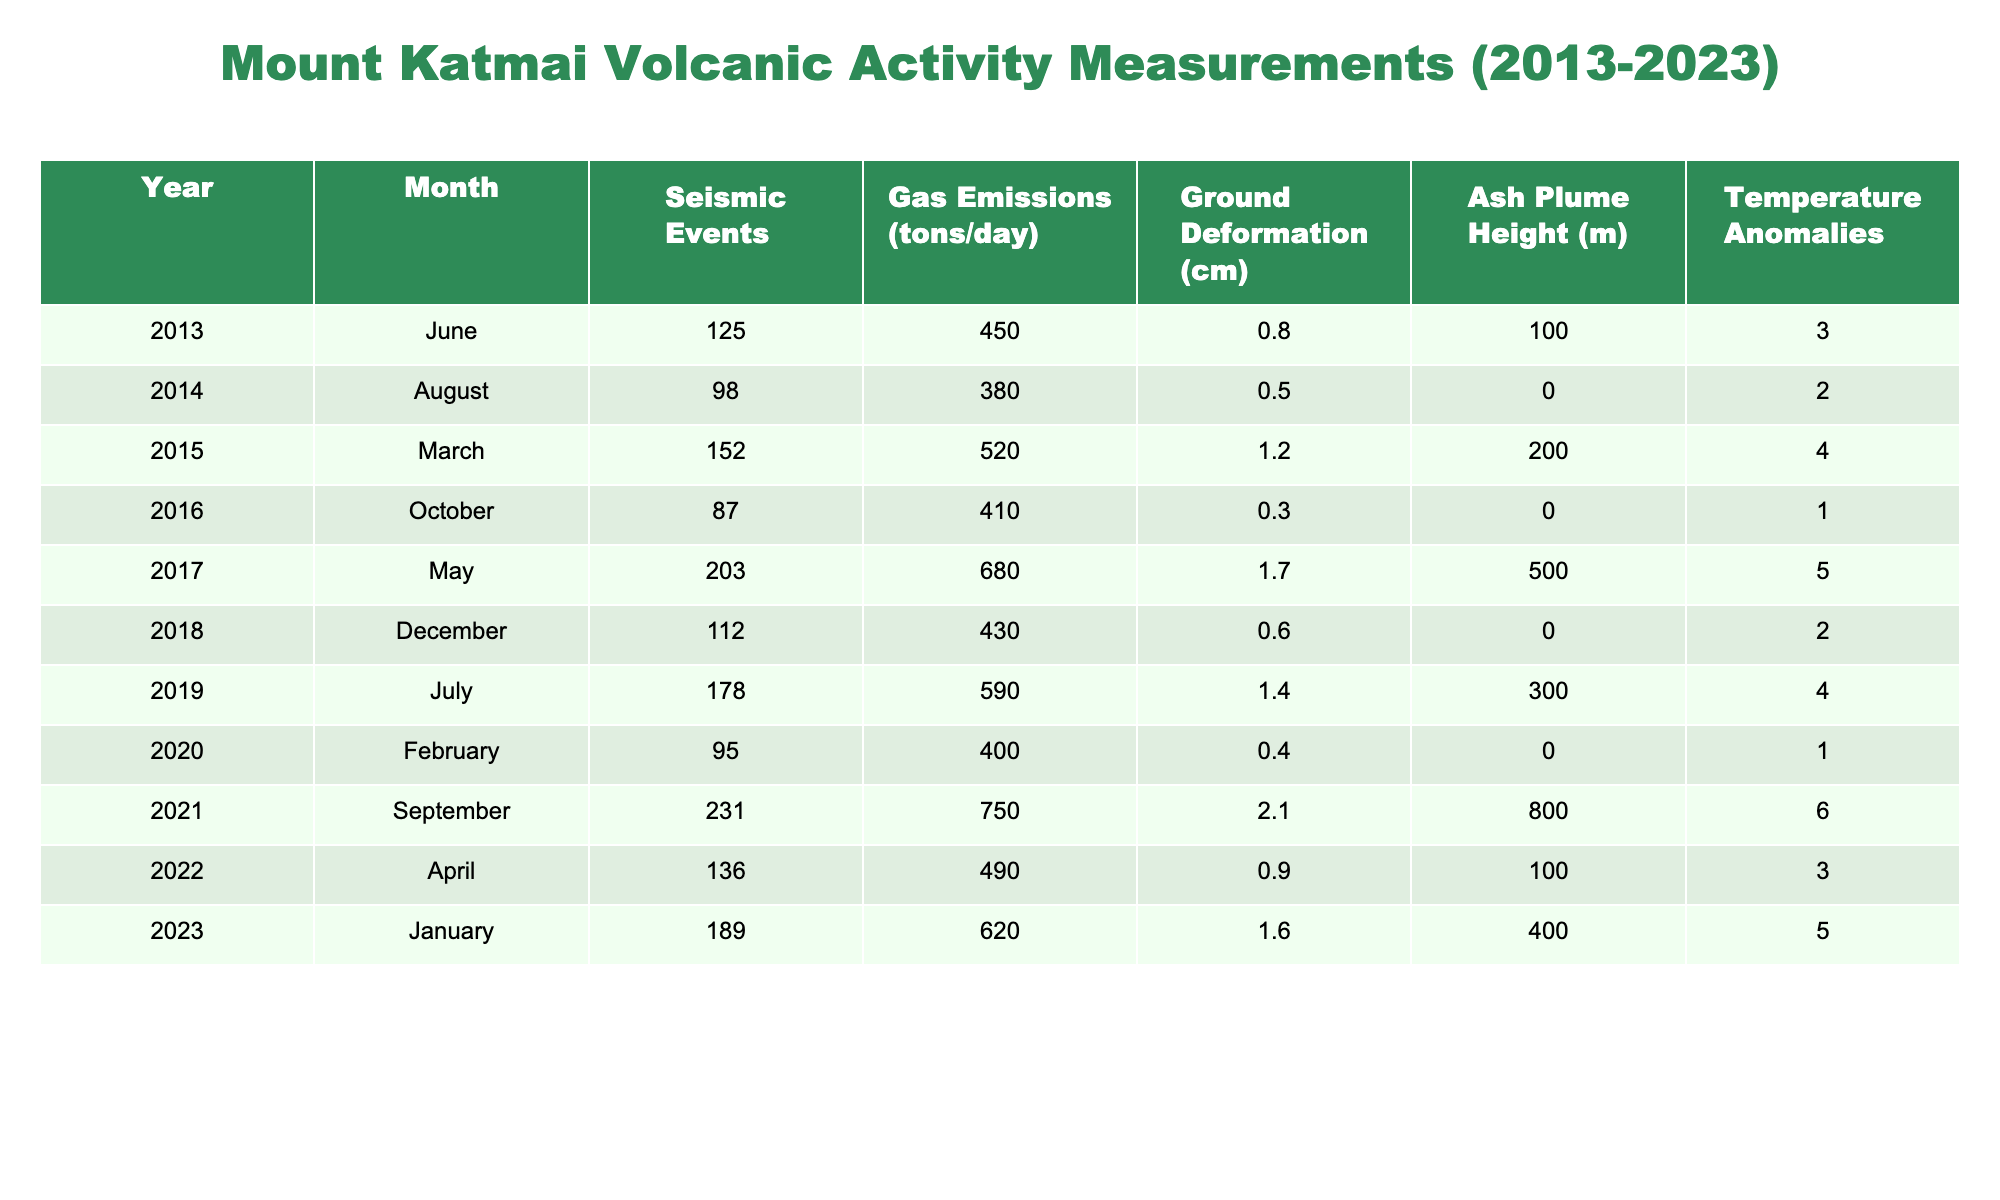What year had the highest number of seismic events? By looking at the column for seismic events, we see that the year 2021 has the highest value, which is 231.
Answer: 2021 What was the average gas emissions in tons per day from 2013 to 2023? First, sum all the gas emissions values: (450 + 380 + 520 + 410 + 680 + 430 + 590 + 400 + 750 + 490 + 620) = 4950. Then, divide by the number of years, which is 11: 4950 / 11 = 450.
Answer: 450 Was there an increase in ground deformation from 2017 to 2021? In 2017, the ground deformation was 1.7 cm and in 2021 it was 2.1 cm. Since 2.1 cm is greater than 1.7 cm, it shows an increase.
Answer: Yes What was the change in ash plume height from 2015 to 2019? The ash plume height in 2015 was 200 m and in 2019 it was 300 m. The change is 300 - 200 = 100 m, indicating an increase.
Answer: 100 m increase What year saw the highest gas emissions while also having the highest number of seismic events? Upon examining the data, 2021 had both the highest gas emissions (750 tons/day) and the highest number of seismic events (231). Thus, both maximums occurred in the same year.
Answer: 2021 What was the temperature anomaly for the year with the highest number of seismic events? In 2021, the number of seismic events was 231, and the corresponding temperature anomaly for that year is 6.
Answer: 6 Which month in 2018 had gas emissions below 500 tons per day? Looking at the table, in December 2018, the gas emissions were 430 tons/day, which is below 500.
Answer: December How many times did the ground deformation exceed 1 cm from 2013 to 2023? Referring to the ground deformation data, it exceeded 1 cm in the years 2015 (1.2 cm), 2017 (1.7 cm), and 2021 (2.1 cm). That’s three instances.
Answer: 3 What was the difference in temperature anomalies between 2013 and 2023? The temperature anomaly in 2013 was 3 and in 2023 was 5. The difference is 5 - 3 = 2.
Answer: 2 Which year had the lowest ash plume height, and what was the height? By reviewing the ash plume heights, we see that the lowest was 0 meters in both 2014 and 2016.
Answer: 2014 and 2016, 0 m 